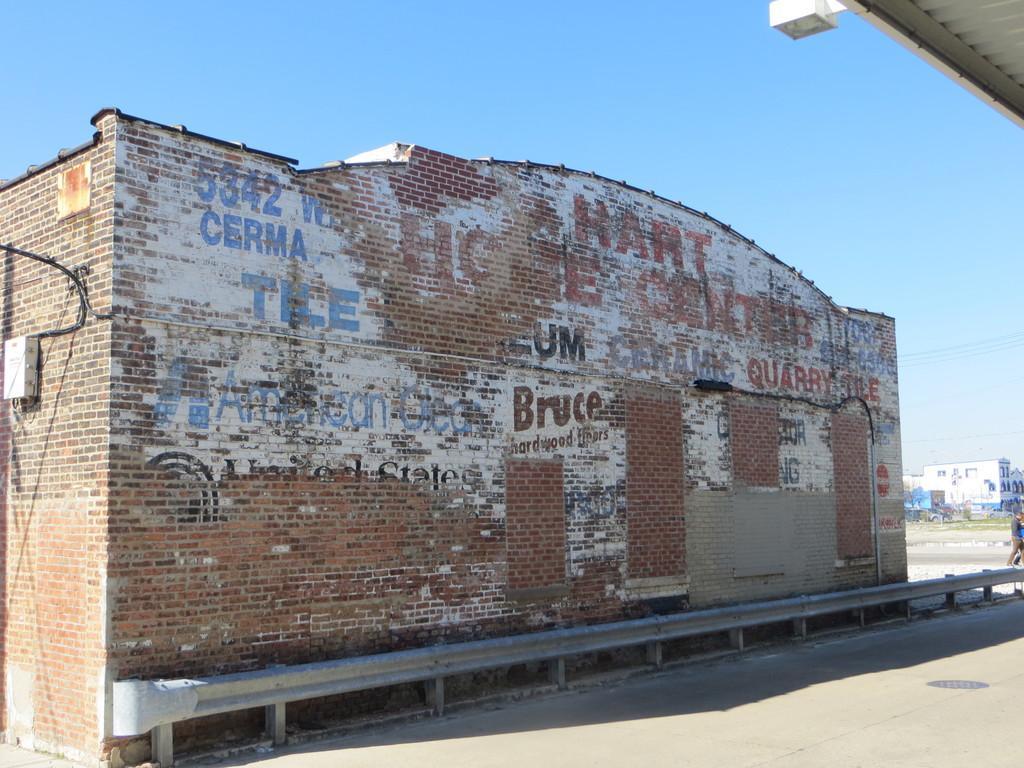Describe this image in one or two sentences. In this image we can see the brick house on which we can see some text, we can see the road, we can see a few people, buildings, wires and the blue color sky in the background. 